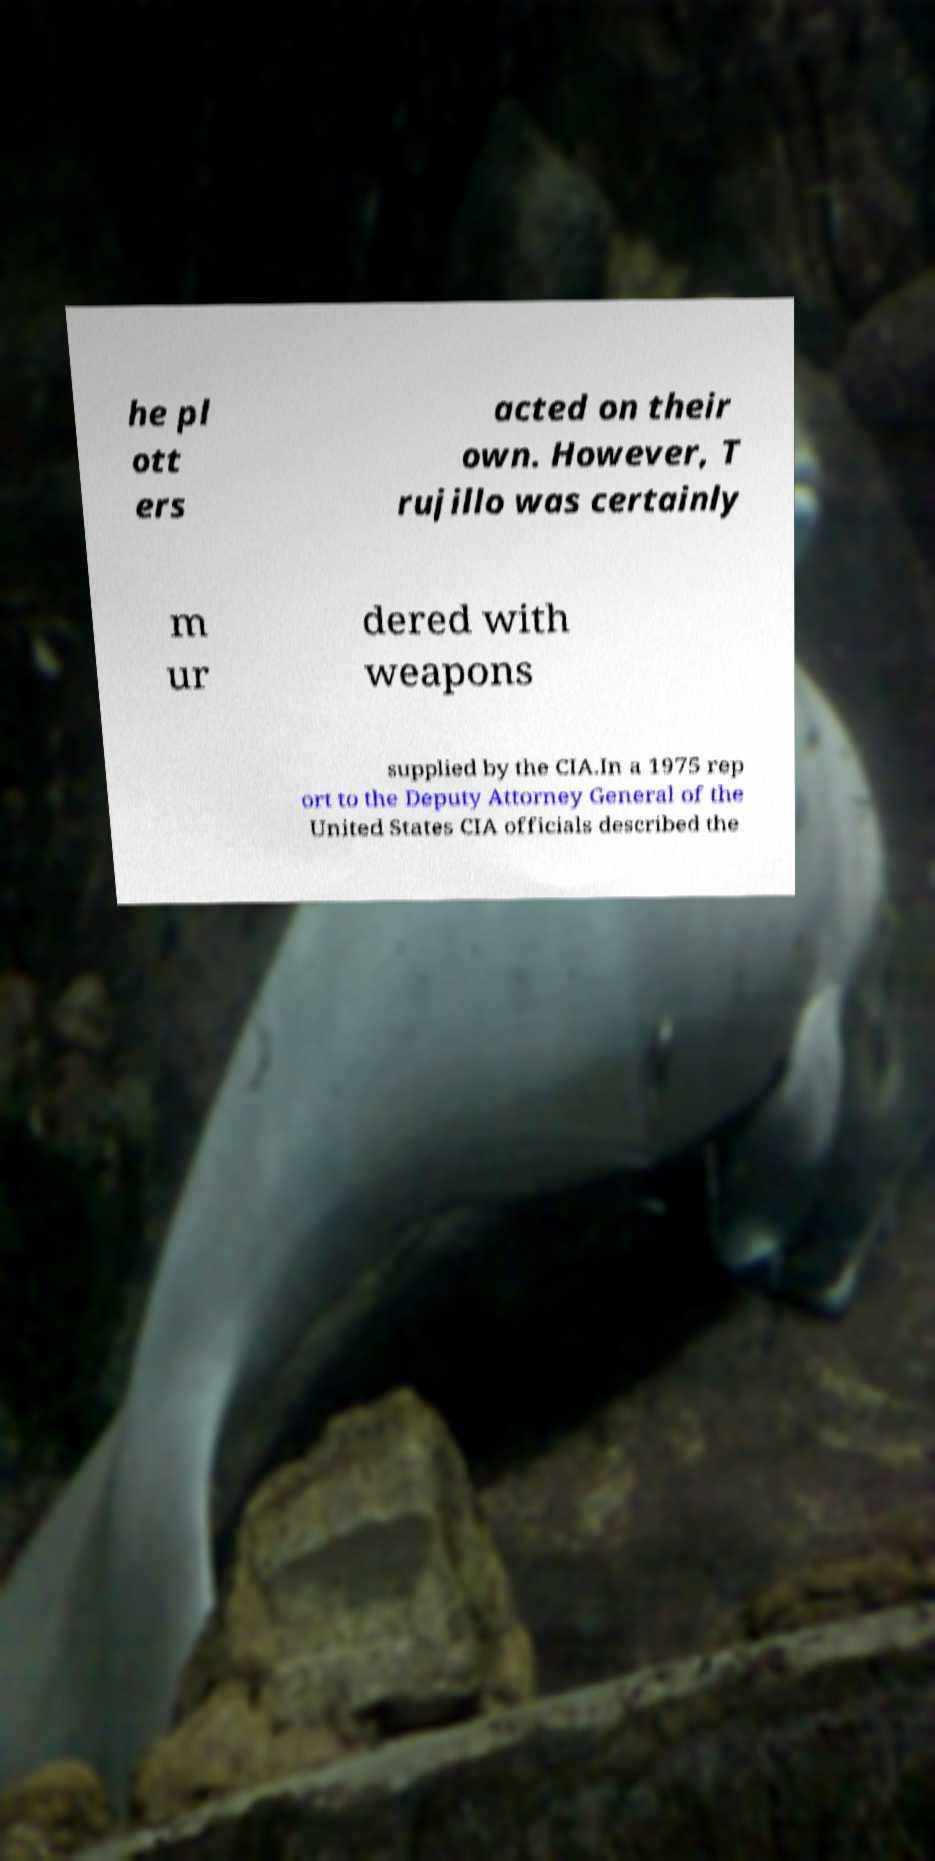Can you read and provide the text displayed in the image?This photo seems to have some interesting text. Can you extract and type it out for me? he pl ott ers acted on their own. However, T rujillo was certainly m ur dered with weapons supplied by the CIA.In a 1975 rep ort to the Deputy Attorney General of the United States CIA officials described the 